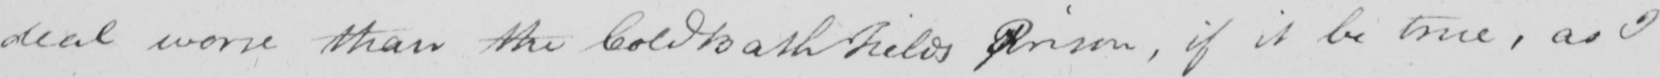What is written in this line of handwriting? deal worse than the Cold Bath Fields Prison , if it be true , as I 